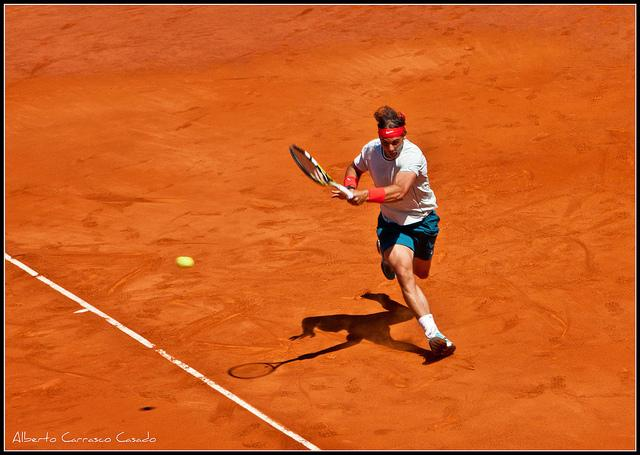Upon what surfaced court is this game being played? Please explain your reasoning. clay. The red color and consistency suggests that this is a clay surface. 